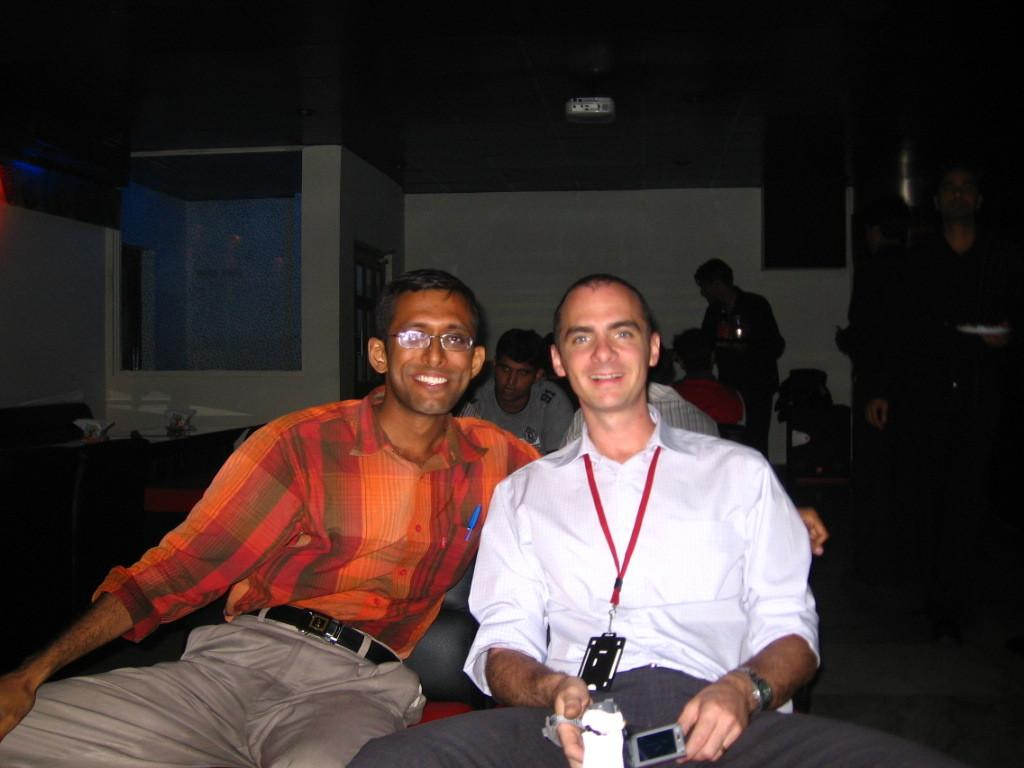How many people are in the image? There are two men in the image. What are the men doing in the image? The men are sitting in chairs and smiling. What is the purpose of their actions in the image? The men are posing for the camera. What can be seen behind the men in the image? There is a wall visible in the image, and the background is dark. What type of brush is the man holding in the image? There is no brush present in the image; the men are sitting in chairs and smiling. 